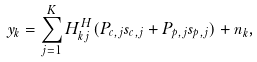Convert formula to latex. <formula><loc_0><loc_0><loc_500><loc_500>y _ { k } = \sum _ { j = 1 } ^ { K } H _ { k j } ^ { H } ( { P } _ { c , j } s _ { c , j } + P _ { p , j } s _ { p , j } ) + n _ { k } ,</formula> 